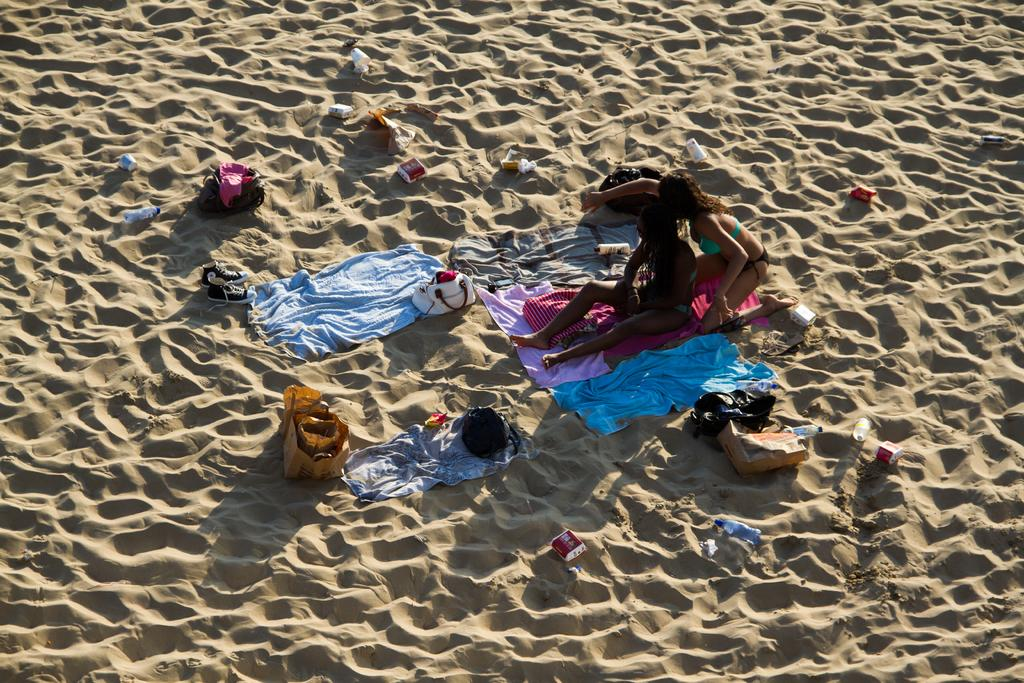Who or what is present in the image? There are people in the image. Can you describe the appearance of the people? The people are wearing colorful clothes. What else can be seen in the image besides the people? There are bags in the image. What is the location of the objects in the image? There are objects on the sand in the image. How many rabbits can be seen hopping on the sand in the image? There are no rabbits present in the image; it only features people and bags on the sand. 